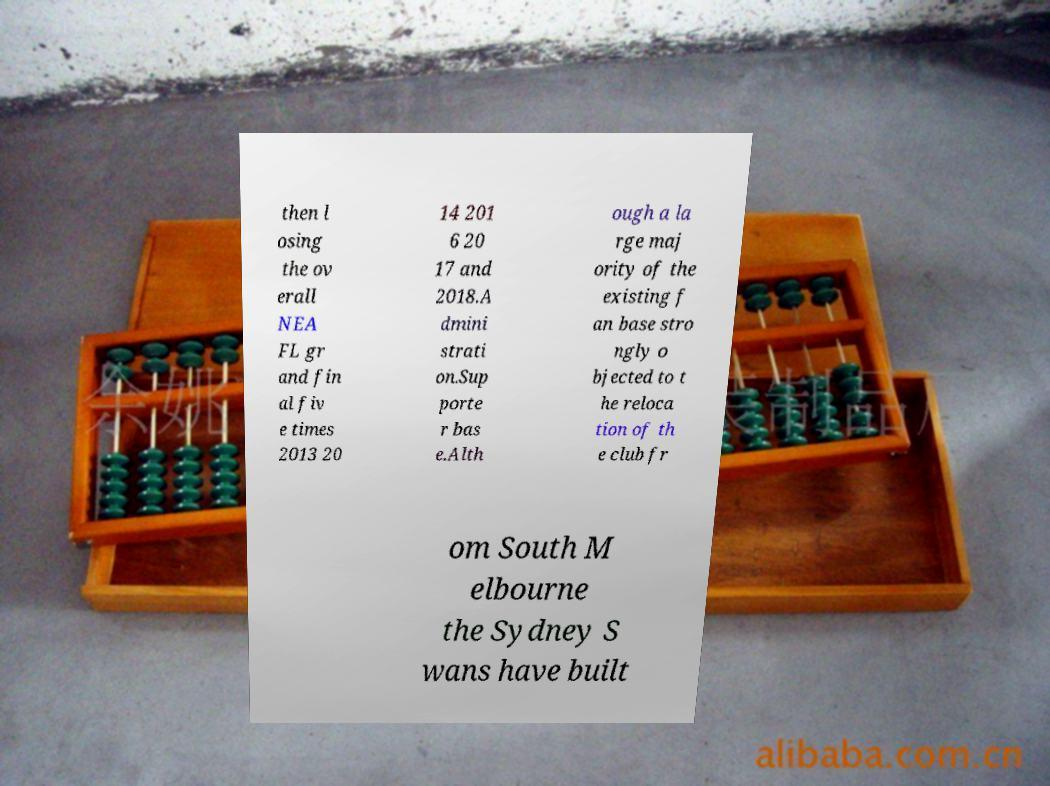Can you accurately transcribe the text from the provided image for me? then l osing the ov erall NEA FL gr and fin al fiv e times 2013 20 14 201 6 20 17 and 2018.A dmini strati on.Sup porte r bas e.Alth ough a la rge maj ority of the existing f an base stro ngly o bjected to t he reloca tion of th e club fr om South M elbourne the Sydney S wans have built 